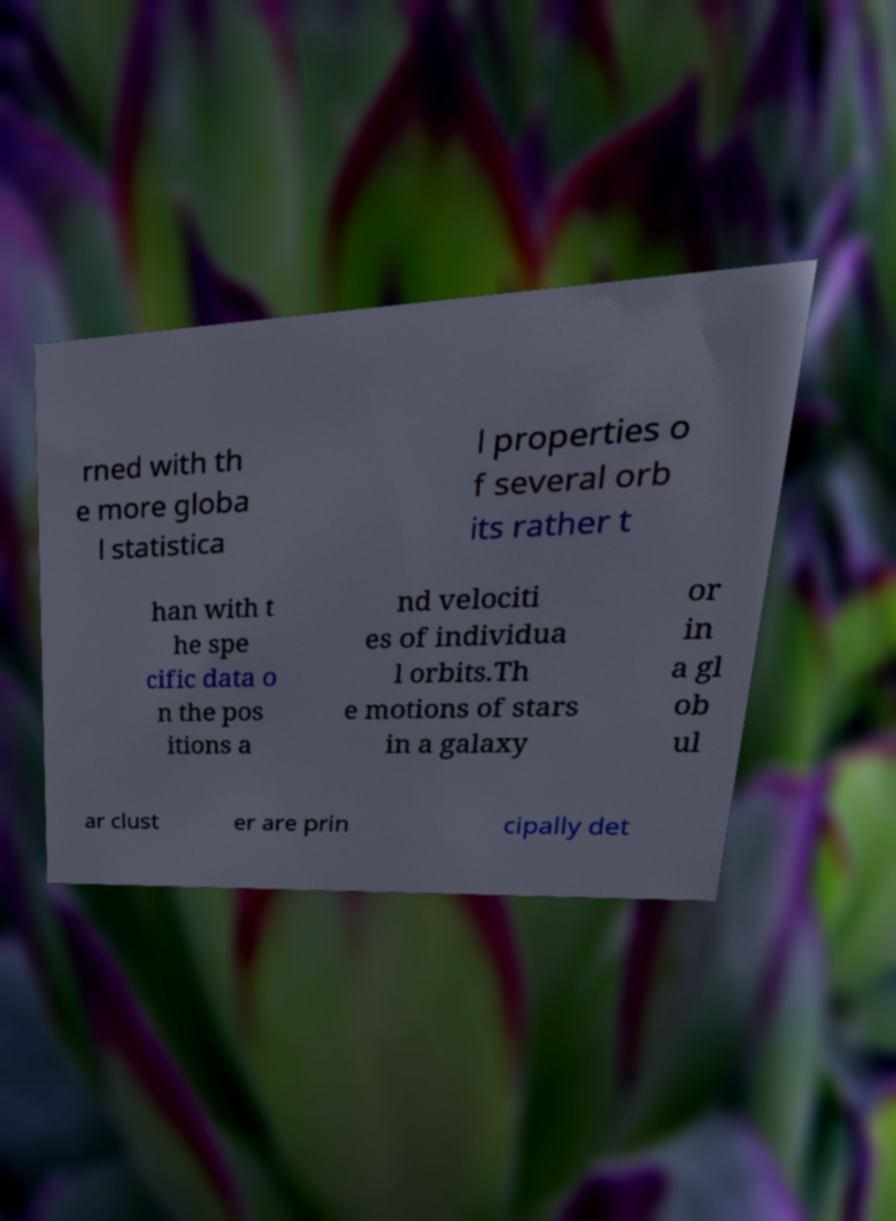Could you assist in decoding the text presented in this image and type it out clearly? rned with th e more globa l statistica l properties o f several orb its rather t han with t he spe cific data o n the pos itions a nd velociti es of individua l orbits.Th e motions of stars in a galaxy or in a gl ob ul ar clust er are prin cipally det 